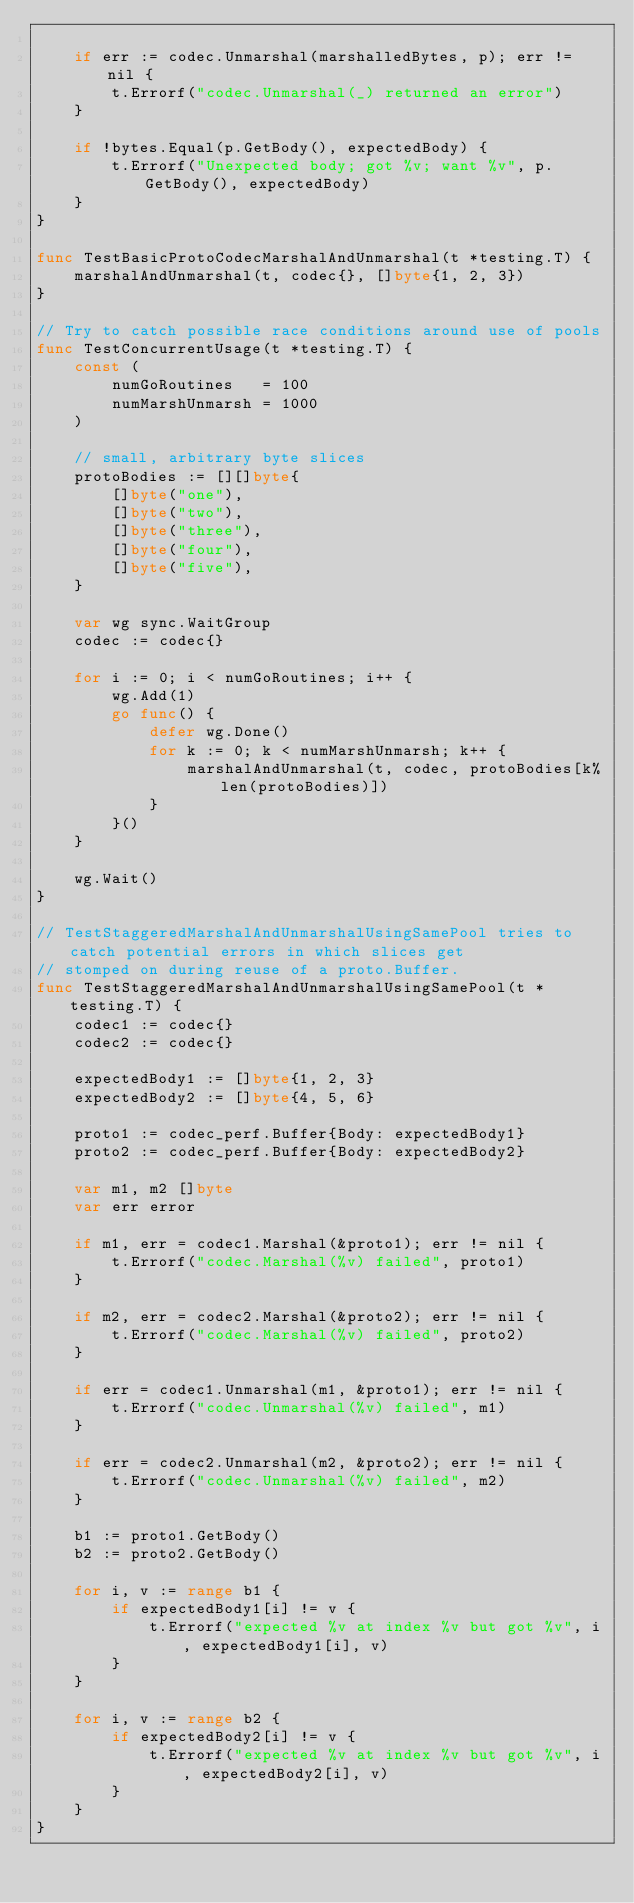<code> <loc_0><loc_0><loc_500><loc_500><_Go_>
	if err := codec.Unmarshal(marshalledBytes, p); err != nil {
		t.Errorf("codec.Unmarshal(_) returned an error")
	}

	if !bytes.Equal(p.GetBody(), expectedBody) {
		t.Errorf("Unexpected body; got %v; want %v", p.GetBody(), expectedBody)
	}
}

func TestBasicProtoCodecMarshalAndUnmarshal(t *testing.T) {
	marshalAndUnmarshal(t, codec{}, []byte{1, 2, 3})
}

// Try to catch possible race conditions around use of pools
func TestConcurrentUsage(t *testing.T) {
	const (
		numGoRoutines   = 100
		numMarshUnmarsh = 1000
	)

	// small, arbitrary byte slices
	protoBodies := [][]byte{
		[]byte("one"),
		[]byte("two"),
		[]byte("three"),
		[]byte("four"),
		[]byte("five"),
	}

	var wg sync.WaitGroup
	codec := codec{}

	for i := 0; i < numGoRoutines; i++ {
		wg.Add(1)
		go func() {
			defer wg.Done()
			for k := 0; k < numMarshUnmarsh; k++ {
				marshalAndUnmarshal(t, codec, protoBodies[k%len(protoBodies)])
			}
		}()
	}

	wg.Wait()
}

// TestStaggeredMarshalAndUnmarshalUsingSamePool tries to catch potential errors in which slices get
// stomped on during reuse of a proto.Buffer.
func TestStaggeredMarshalAndUnmarshalUsingSamePool(t *testing.T) {
	codec1 := codec{}
	codec2 := codec{}

	expectedBody1 := []byte{1, 2, 3}
	expectedBody2 := []byte{4, 5, 6}

	proto1 := codec_perf.Buffer{Body: expectedBody1}
	proto2 := codec_perf.Buffer{Body: expectedBody2}

	var m1, m2 []byte
	var err error

	if m1, err = codec1.Marshal(&proto1); err != nil {
		t.Errorf("codec.Marshal(%v) failed", proto1)
	}

	if m2, err = codec2.Marshal(&proto2); err != nil {
		t.Errorf("codec.Marshal(%v) failed", proto2)
	}

	if err = codec1.Unmarshal(m1, &proto1); err != nil {
		t.Errorf("codec.Unmarshal(%v) failed", m1)
	}

	if err = codec2.Unmarshal(m2, &proto2); err != nil {
		t.Errorf("codec.Unmarshal(%v) failed", m2)
	}

	b1 := proto1.GetBody()
	b2 := proto2.GetBody()

	for i, v := range b1 {
		if expectedBody1[i] != v {
			t.Errorf("expected %v at index %v but got %v", i, expectedBody1[i], v)
		}
	}

	for i, v := range b2 {
		if expectedBody2[i] != v {
			t.Errorf("expected %v at index %v but got %v", i, expectedBody2[i], v)
		}
	}
}
</code> 